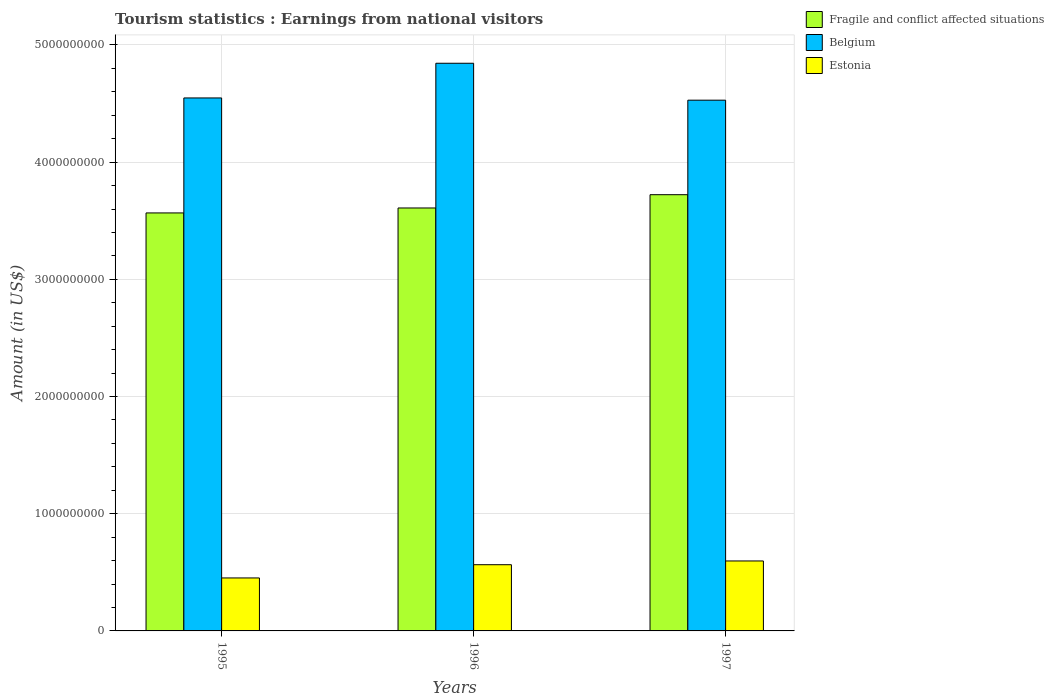How many groups of bars are there?
Provide a short and direct response. 3. Are the number of bars per tick equal to the number of legend labels?
Keep it short and to the point. Yes. Are the number of bars on each tick of the X-axis equal?
Provide a short and direct response. Yes. How many bars are there on the 1st tick from the right?
Make the answer very short. 3. In how many cases, is the number of bars for a given year not equal to the number of legend labels?
Give a very brief answer. 0. What is the earnings from national visitors in Estonia in 1997?
Keep it short and to the point. 5.97e+08. Across all years, what is the maximum earnings from national visitors in Fragile and conflict affected situations?
Offer a very short reply. 3.72e+09. Across all years, what is the minimum earnings from national visitors in Belgium?
Ensure brevity in your answer.  4.53e+09. What is the total earnings from national visitors in Belgium in the graph?
Offer a very short reply. 1.39e+1. What is the difference between the earnings from national visitors in Estonia in 1995 and that in 1997?
Give a very brief answer. -1.45e+08. What is the difference between the earnings from national visitors in Fragile and conflict affected situations in 1996 and the earnings from national visitors in Belgium in 1995?
Provide a succinct answer. -9.39e+08. What is the average earnings from national visitors in Belgium per year?
Ensure brevity in your answer.  4.64e+09. In the year 1996, what is the difference between the earnings from national visitors in Belgium and earnings from national visitors in Fragile and conflict affected situations?
Provide a succinct answer. 1.23e+09. In how many years, is the earnings from national visitors in Belgium greater than 600000000 US$?
Keep it short and to the point. 3. What is the ratio of the earnings from national visitors in Fragile and conflict affected situations in 1995 to that in 1997?
Your answer should be compact. 0.96. What is the difference between the highest and the second highest earnings from national visitors in Fragile and conflict affected situations?
Ensure brevity in your answer.  1.13e+08. What is the difference between the highest and the lowest earnings from national visitors in Belgium?
Ensure brevity in your answer.  3.15e+08. Is the sum of the earnings from national visitors in Fragile and conflict affected situations in 1996 and 1997 greater than the maximum earnings from national visitors in Estonia across all years?
Your answer should be compact. Yes. What does the 2nd bar from the left in 1995 represents?
Ensure brevity in your answer.  Belgium. How many bars are there?
Your response must be concise. 9. Are all the bars in the graph horizontal?
Give a very brief answer. No. How many years are there in the graph?
Your answer should be compact. 3. What is the difference between two consecutive major ticks on the Y-axis?
Keep it short and to the point. 1.00e+09. Are the values on the major ticks of Y-axis written in scientific E-notation?
Your response must be concise. No. Does the graph contain grids?
Provide a succinct answer. Yes. How many legend labels are there?
Make the answer very short. 3. What is the title of the graph?
Your answer should be very brief. Tourism statistics : Earnings from national visitors. Does "Equatorial Guinea" appear as one of the legend labels in the graph?
Offer a very short reply. No. What is the label or title of the Y-axis?
Your answer should be very brief. Amount (in US$). What is the Amount (in US$) in Fragile and conflict affected situations in 1995?
Provide a succinct answer. 3.57e+09. What is the Amount (in US$) of Belgium in 1995?
Your answer should be compact. 4.55e+09. What is the Amount (in US$) of Estonia in 1995?
Your answer should be compact. 4.52e+08. What is the Amount (in US$) in Fragile and conflict affected situations in 1996?
Keep it short and to the point. 3.61e+09. What is the Amount (in US$) of Belgium in 1996?
Offer a terse response. 4.84e+09. What is the Amount (in US$) in Estonia in 1996?
Ensure brevity in your answer.  5.65e+08. What is the Amount (in US$) of Fragile and conflict affected situations in 1997?
Provide a succinct answer. 3.72e+09. What is the Amount (in US$) in Belgium in 1997?
Your response must be concise. 4.53e+09. What is the Amount (in US$) in Estonia in 1997?
Give a very brief answer. 5.97e+08. Across all years, what is the maximum Amount (in US$) of Fragile and conflict affected situations?
Your answer should be compact. 3.72e+09. Across all years, what is the maximum Amount (in US$) in Belgium?
Offer a terse response. 4.84e+09. Across all years, what is the maximum Amount (in US$) of Estonia?
Offer a terse response. 5.97e+08. Across all years, what is the minimum Amount (in US$) in Fragile and conflict affected situations?
Your response must be concise. 3.57e+09. Across all years, what is the minimum Amount (in US$) in Belgium?
Ensure brevity in your answer.  4.53e+09. Across all years, what is the minimum Amount (in US$) of Estonia?
Ensure brevity in your answer.  4.52e+08. What is the total Amount (in US$) of Fragile and conflict affected situations in the graph?
Your response must be concise. 1.09e+1. What is the total Amount (in US$) in Belgium in the graph?
Provide a succinct answer. 1.39e+1. What is the total Amount (in US$) of Estonia in the graph?
Make the answer very short. 1.61e+09. What is the difference between the Amount (in US$) of Fragile and conflict affected situations in 1995 and that in 1996?
Your answer should be very brief. -4.22e+07. What is the difference between the Amount (in US$) of Belgium in 1995 and that in 1996?
Provide a succinct answer. -2.96e+08. What is the difference between the Amount (in US$) of Estonia in 1995 and that in 1996?
Your answer should be compact. -1.13e+08. What is the difference between the Amount (in US$) in Fragile and conflict affected situations in 1995 and that in 1997?
Offer a terse response. -1.56e+08. What is the difference between the Amount (in US$) of Belgium in 1995 and that in 1997?
Make the answer very short. 1.90e+07. What is the difference between the Amount (in US$) of Estonia in 1995 and that in 1997?
Make the answer very short. -1.45e+08. What is the difference between the Amount (in US$) in Fragile and conflict affected situations in 1996 and that in 1997?
Your answer should be compact. -1.13e+08. What is the difference between the Amount (in US$) of Belgium in 1996 and that in 1997?
Give a very brief answer. 3.15e+08. What is the difference between the Amount (in US$) in Estonia in 1996 and that in 1997?
Your response must be concise. -3.20e+07. What is the difference between the Amount (in US$) in Fragile and conflict affected situations in 1995 and the Amount (in US$) in Belgium in 1996?
Offer a terse response. -1.28e+09. What is the difference between the Amount (in US$) of Fragile and conflict affected situations in 1995 and the Amount (in US$) of Estonia in 1996?
Make the answer very short. 3.00e+09. What is the difference between the Amount (in US$) in Belgium in 1995 and the Amount (in US$) in Estonia in 1996?
Give a very brief answer. 3.98e+09. What is the difference between the Amount (in US$) in Fragile and conflict affected situations in 1995 and the Amount (in US$) in Belgium in 1997?
Provide a succinct answer. -9.62e+08. What is the difference between the Amount (in US$) of Fragile and conflict affected situations in 1995 and the Amount (in US$) of Estonia in 1997?
Keep it short and to the point. 2.97e+09. What is the difference between the Amount (in US$) in Belgium in 1995 and the Amount (in US$) in Estonia in 1997?
Your response must be concise. 3.95e+09. What is the difference between the Amount (in US$) in Fragile and conflict affected situations in 1996 and the Amount (in US$) in Belgium in 1997?
Keep it short and to the point. -9.20e+08. What is the difference between the Amount (in US$) in Fragile and conflict affected situations in 1996 and the Amount (in US$) in Estonia in 1997?
Offer a very short reply. 3.01e+09. What is the difference between the Amount (in US$) in Belgium in 1996 and the Amount (in US$) in Estonia in 1997?
Make the answer very short. 4.25e+09. What is the average Amount (in US$) in Fragile and conflict affected situations per year?
Provide a succinct answer. 3.63e+09. What is the average Amount (in US$) in Belgium per year?
Your answer should be compact. 4.64e+09. What is the average Amount (in US$) of Estonia per year?
Offer a terse response. 5.38e+08. In the year 1995, what is the difference between the Amount (in US$) of Fragile and conflict affected situations and Amount (in US$) of Belgium?
Make the answer very short. -9.81e+08. In the year 1995, what is the difference between the Amount (in US$) in Fragile and conflict affected situations and Amount (in US$) in Estonia?
Provide a short and direct response. 3.11e+09. In the year 1995, what is the difference between the Amount (in US$) in Belgium and Amount (in US$) in Estonia?
Give a very brief answer. 4.10e+09. In the year 1996, what is the difference between the Amount (in US$) in Fragile and conflict affected situations and Amount (in US$) in Belgium?
Provide a short and direct response. -1.23e+09. In the year 1996, what is the difference between the Amount (in US$) in Fragile and conflict affected situations and Amount (in US$) in Estonia?
Offer a very short reply. 3.04e+09. In the year 1996, what is the difference between the Amount (in US$) in Belgium and Amount (in US$) in Estonia?
Your answer should be very brief. 4.28e+09. In the year 1997, what is the difference between the Amount (in US$) in Fragile and conflict affected situations and Amount (in US$) in Belgium?
Your response must be concise. -8.07e+08. In the year 1997, what is the difference between the Amount (in US$) of Fragile and conflict affected situations and Amount (in US$) of Estonia?
Provide a succinct answer. 3.13e+09. In the year 1997, what is the difference between the Amount (in US$) in Belgium and Amount (in US$) in Estonia?
Your response must be concise. 3.93e+09. What is the ratio of the Amount (in US$) of Fragile and conflict affected situations in 1995 to that in 1996?
Your response must be concise. 0.99. What is the ratio of the Amount (in US$) in Belgium in 1995 to that in 1996?
Provide a short and direct response. 0.94. What is the ratio of the Amount (in US$) of Estonia in 1995 to that in 1996?
Offer a terse response. 0.8. What is the ratio of the Amount (in US$) in Fragile and conflict affected situations in 1995 to that in 1997?
Provide a succinct answer. 0.96. What is the ratio of the Amount (in US$) of Estonia in 1995 to that in 1997?
Your answer should be compact. 0.76. What is the ratio of the Amount (in US$) of Fragile and conflict affected situations in 1996 to that in 1997?
Ensure brevity in your answer.  0.97. What is the ratio of the Amount (in US$) in Belgium in 1996 to that in 1997?
Provide a short and direct response. 1.07. What is the ratio of the Amount (in US$) in Estonia in 1996 to that in 1997?
Ensure brevity in your answer.  0.95. What is the difference between the highest and the second highest Amount (in US$) in Fragile and conflict affected situations?
Provide a short and direct response. 1.13e+08. What is the difference between the highest and the second highest Amount (in US$) in Belgium?
Provide a short and direct response. 2.96e+08. What is the difference between the highest and the second highest Amount (in US$) of Estonia?
Provide a succinct answer. 3.20e+07. What is the difference between the highest and the lowest Amount (in US$) in Fragile and conflict affected situations?
Your answer should be very brief. 1.56e+08. What is the difference between the highest and the lowest Amount (in US$) in Belgium?
Keep it short and to the point. 3.15e+08. What is the difference between the highest and the lowest Amount (in US$) in Estonia?
Make the answer very short. 1.45e+08. 